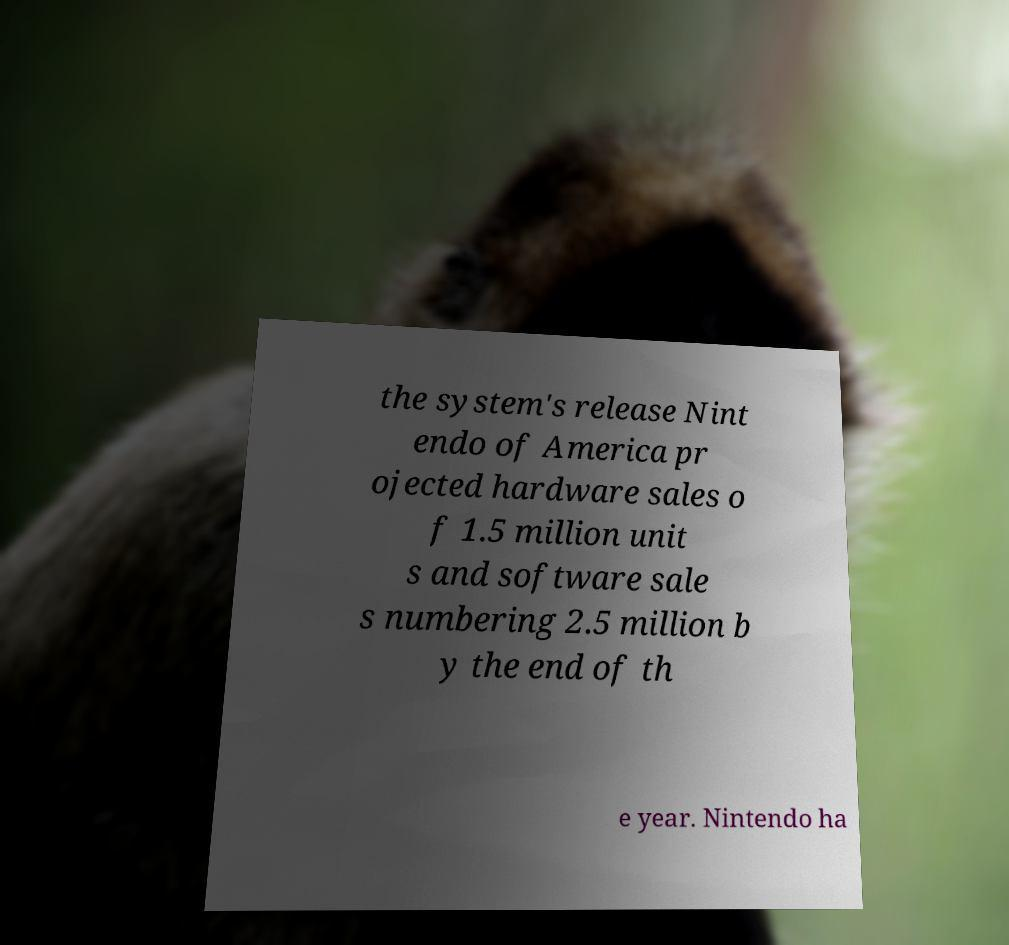There's text embedded in this image that I need extracted. Can you transcribe it verbatim? the system's release Nint endo of America pr ojected hardware sales o f 1.5 million unit s and software sale s numbering 2.5 million b y the end of th e year. Nintendo ha 